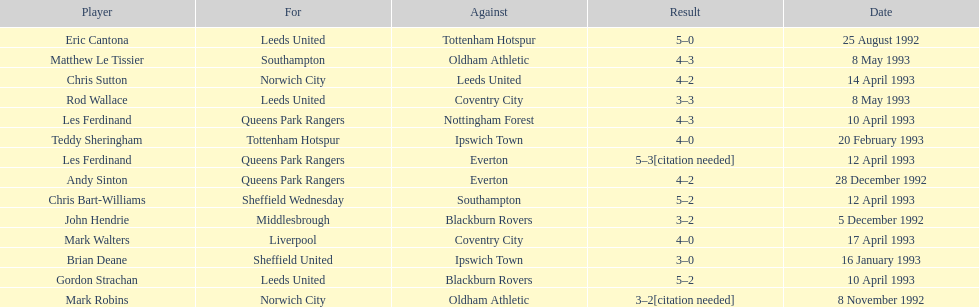Can you parse all the data within this table? {'header': ['Player', 'For', 'Against', 'Result', 'Date'], 'rows': [['Eric Cantona', 'Leeds United', 'Tottenham Hotspur', '5–0', '25 August 1992'], ['Matthew Le Tissier', 'Southampton', 'Oldham Athletic', '4–3', '8 May 1993'], ['Chris Sutton', 'Norwich City', 'Leeds United', '4–2', '14 April 1993'], ['Rod Wallace', 'Leeds United', 'Coventry City', '3–3', '8 May 1993'], ['Les Ferdinand', 'Queens Park Rangers', 'Nottingham Forest', '4–3', '10 April 1993'], ['Teddy Sheringham', 'Tottenham Hotspur', 'Ipswich Town', '4–0', '20 February 1993'], ['Les Ferdinand', 'Queens Park Rangers', 'Everton', '5–3[citation needed]', '12 April 1993'], ['Andy Sinton', 'Queens Park Rangers', 'Everton', '4–2', '28 December 1992'], ['Chris Bart-Williams', 'Sheffield Wednesday', 'Southampton', '5–2', '12 April 1993'], ['John Hendrie', 'Middlesbrough', 'Blackburn Rovers', '3–2', '5 December 1992'], ['Mark Walters', 'Liverpool', 'Coventry City', '4–0', '17 April 1993'], ['Brian Deane', 'Sheffield United', 'Ipswich Town', '3–0', '16 January 1993'], ['Gordon Strachan', 'Leeds United', 'Blackburn Rovers', '5–2', '10 April 1993'], ['Mark Robins', 'Norwich City', 'Oldham Athletic', '3–2[citation needed]', '8 November 1992']]} Which team did liverpool play against? Coventry City. 